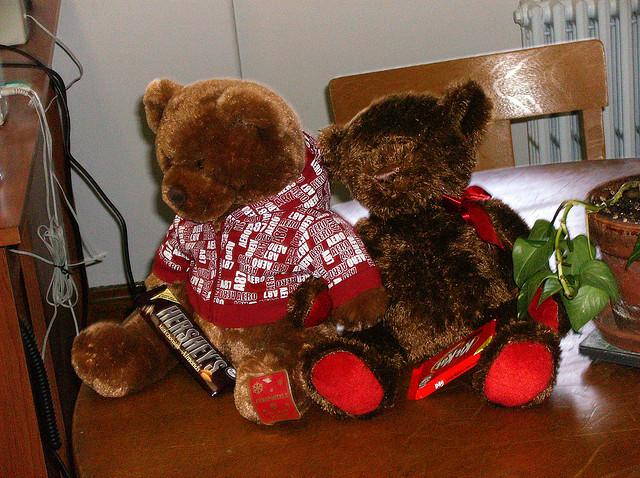What kind of candy bar is hanging on the leg of the teddy with a hoodie sweater put on?

Choices:
A) kit kat
B) hersheys
C) payday
D) mars hersheys 